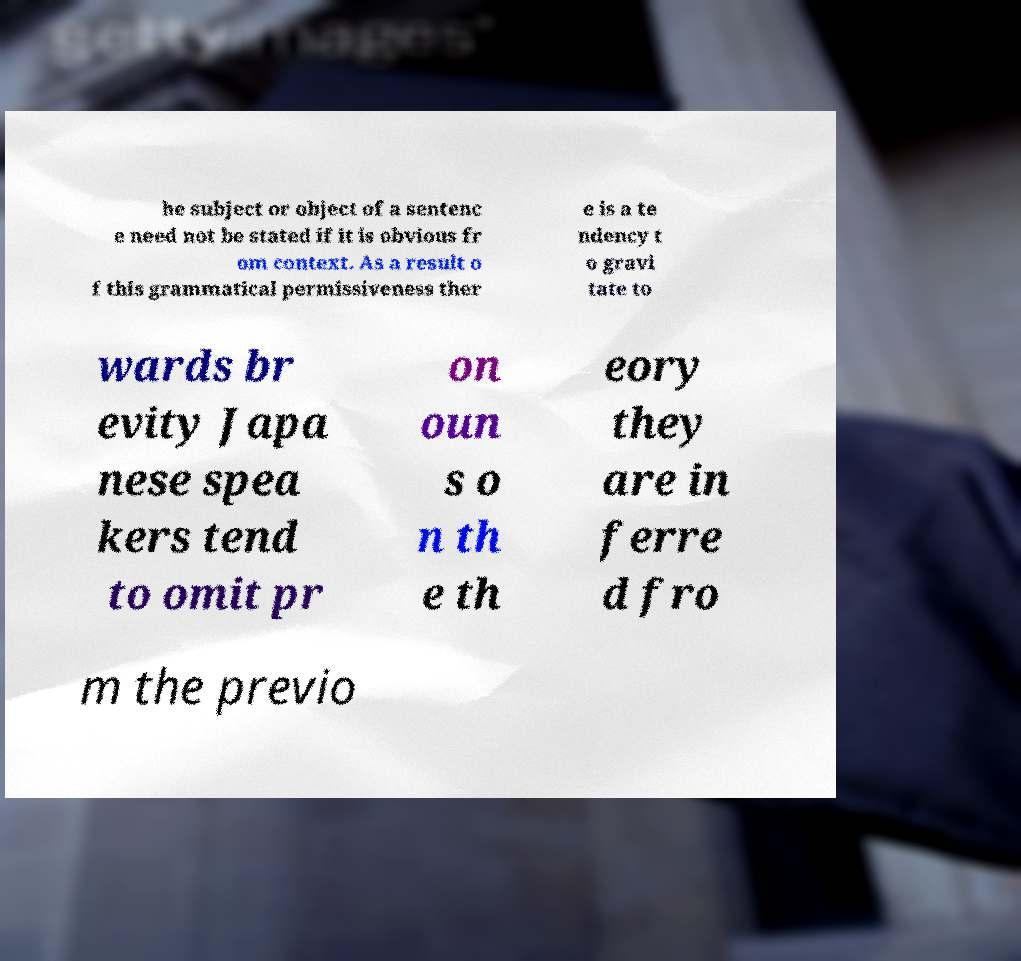Could you assist in decoding the text presented in this image and type it out clearly? he subject or object of a sentenc e need not be stated if it is obvious fr om context. As a result o f this grammatical permissiveness ther e is a te ndency t o gravi tate to wards br evity Japa nese spea kers tend to omit pr on oun s o n th e th eory they are in ferre d fro m the previo 